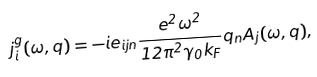Convert formula to latex. <formula><loc_0><loc_0><loc_500><loc_500>j ^ { g } _ { i } ( \omega , { q } ) = - i e _ { i j n } \frac { e ^ { 2 } \omega ^ { 2 } } { 1 2 \pi ^ { 2 } \gamma _ { 0 } k _ { F } } q _ { n } { A _ { j } } ( \omega , { q } ) ,</formula> 